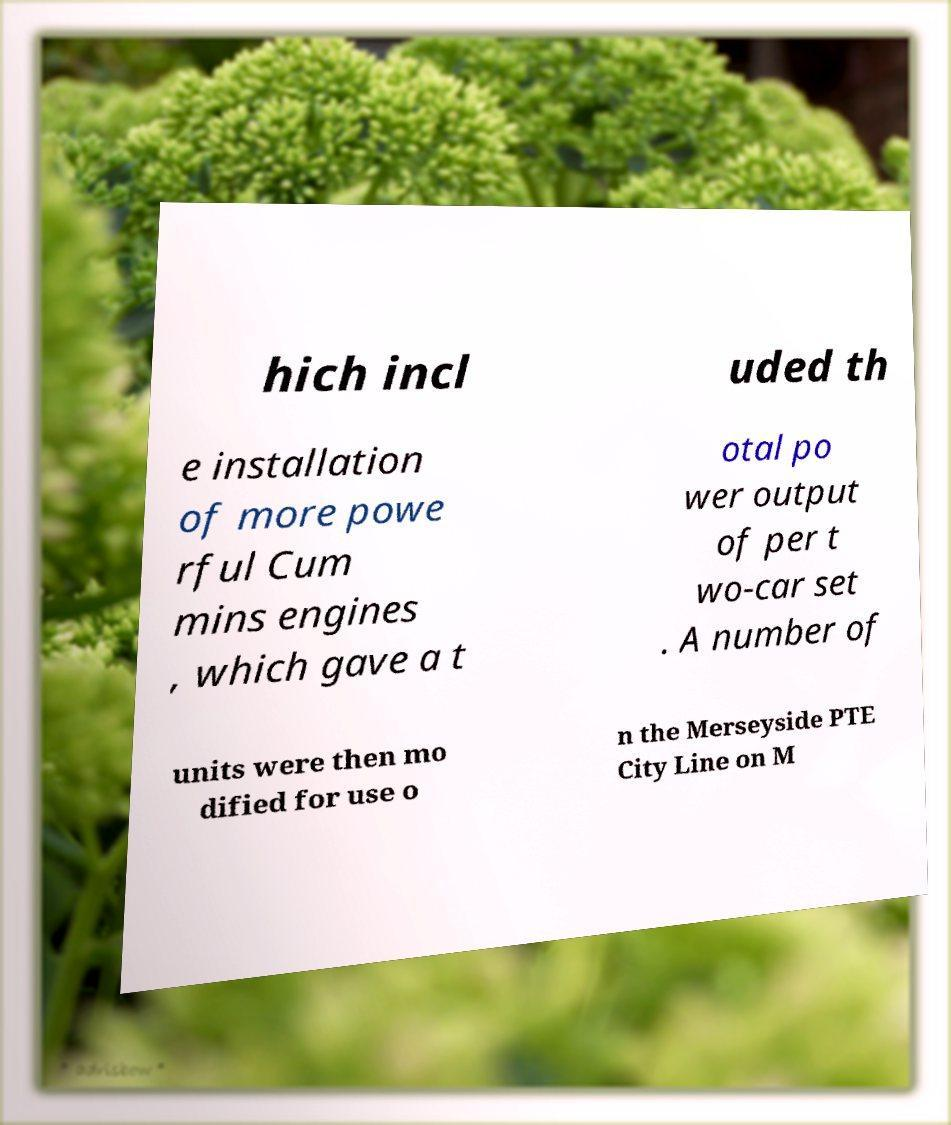Could you assist in decoding the text presented in this image and type it out clearly? hich incl uded th e installation of more powe rful Cum mins engines , which gave a t otal po wer output of per t wo-car set . A number of units were then mo dified for use o n the Merseyside PTE City Line on M 